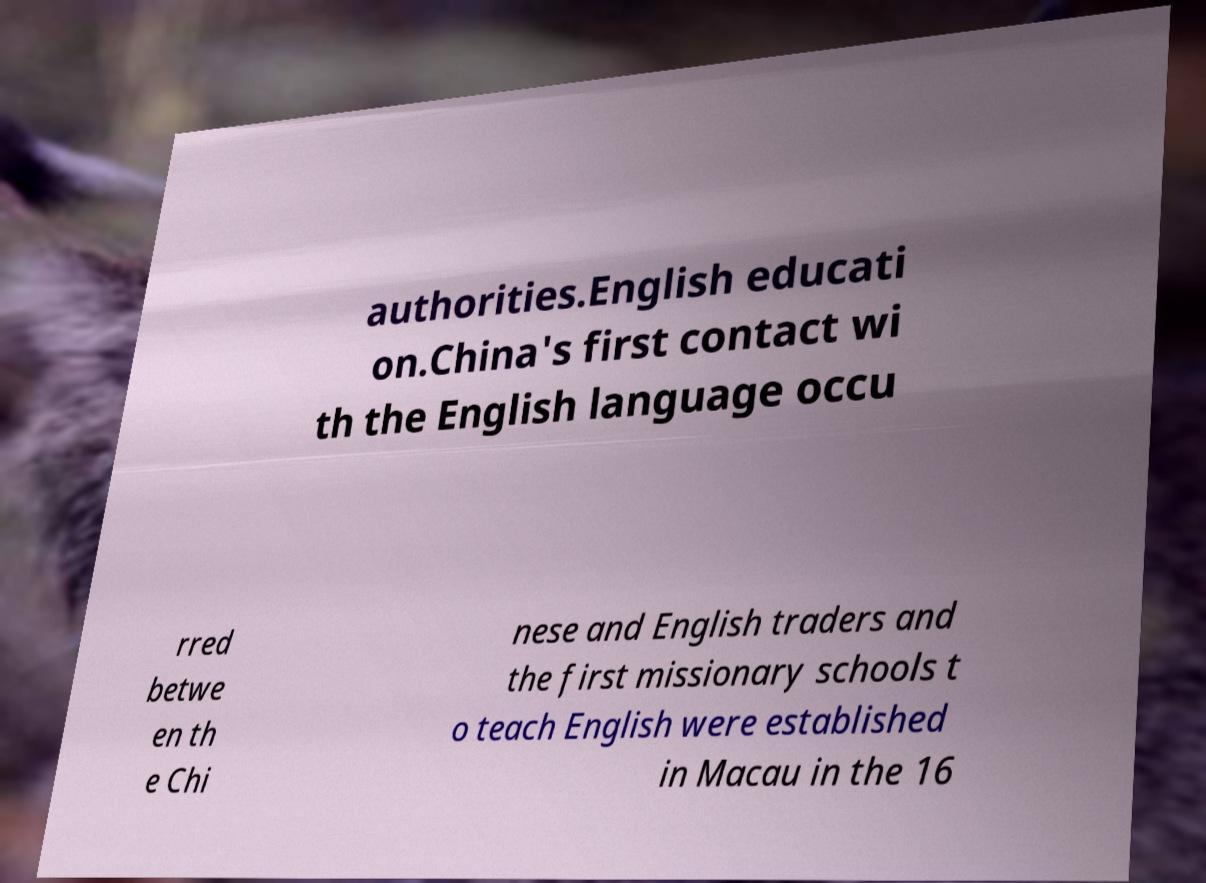Could you extract and type out the text from this image? authorities.English educati on.China's first contact wi th the English language occu rred betwe en th e Chi nese and English traders and the first missionary schools t o teach English were established in Macau in the 16 